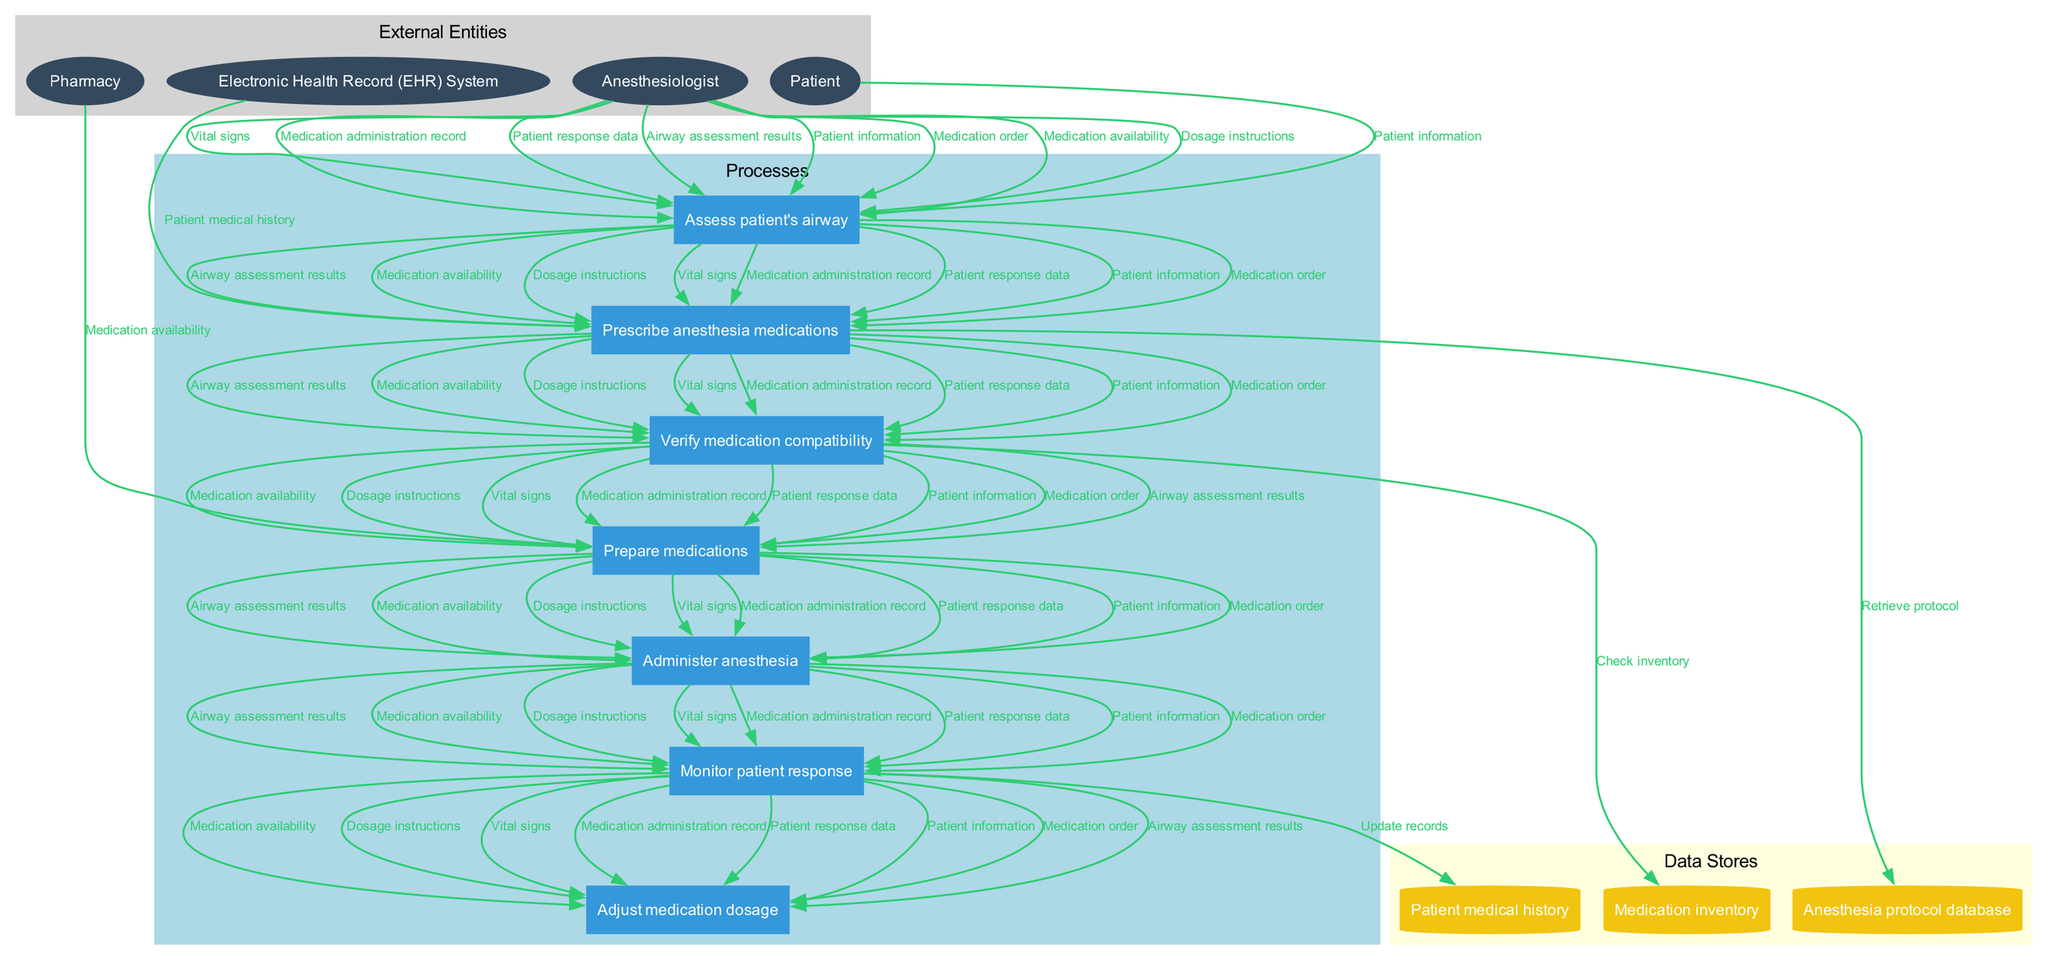What are the external entities in the diagram? The external entities are highlighted in the diagram under the "External Entities" category, and they include "Anesthesiologist," "Patient," "Pharmacy," and "Electronic Health Record (EHR) System."
Answer: Anesthesiologist, Patient, Pharmacy, Electronic Health Record (EHR) System How many processes are defined in the diagram? The diagram lists processes under the "Processes" cluster, and there are a total of seven processes: "Assess patient's airway," "Prescribe anesthesia medications," "Verify medication compatibility," "Prepare medications," "Administer anesthesia," "Monitor patient response," and "Adjust medication dosage."
Answer: Seven Which process involves checking medication compatibility? The diagram shows that "Verify medication compatibility" is the specific process focused on checking that the prescribed medications are compatible before preparation and administration.
Answer: Verify medication compatibility What data flow connects the patient to their airway assessment? According to the diagram, the data flow labeled "Patient information" connects the "Patient" external entity to the "Assess patient's airway" process, indicating the information regarding the patient that is required for the assessment.
Answer: Patient information Which data store is connected to updating patient records during monitoring? The diagram indicates that during the "Monitor patient response" process, the data store "Patient medical history" is updated to reflect the patient's current status and response to anesthesia.
Answer: Patient medical history What process follows the administration of anesthesia? In the flow of processes illustrated in the diagram, after "Administer anesthesia," the following process is "Monitor patient response," showing the sequence of actions taken after anesthesia is given.
Answer: Monitor patient response How does the EHR system contribute to the anesthesia process? The diagram illustrates that the "Electronic Health Record (EHR) System" supplies the "Patient medical history" to the process "Prescribe anesthesia medications," providing essential background information for safe prescribing.
Answer: Patient medical history What type of data is required to prepare medications? The diagram indicates that "Medication availability" data flow is necessary for the "Prepare medications" process, ensuring that the correct medications are in stock before they are prepared for administration.
Answer: Medication availability Which external entity is responsible for preparing medications? The connection in the diagram shows that the "Pharmacy" external entity is responsible for supplying and preparing the required medications for anesthesia administration.
Answer: Pharmacy 